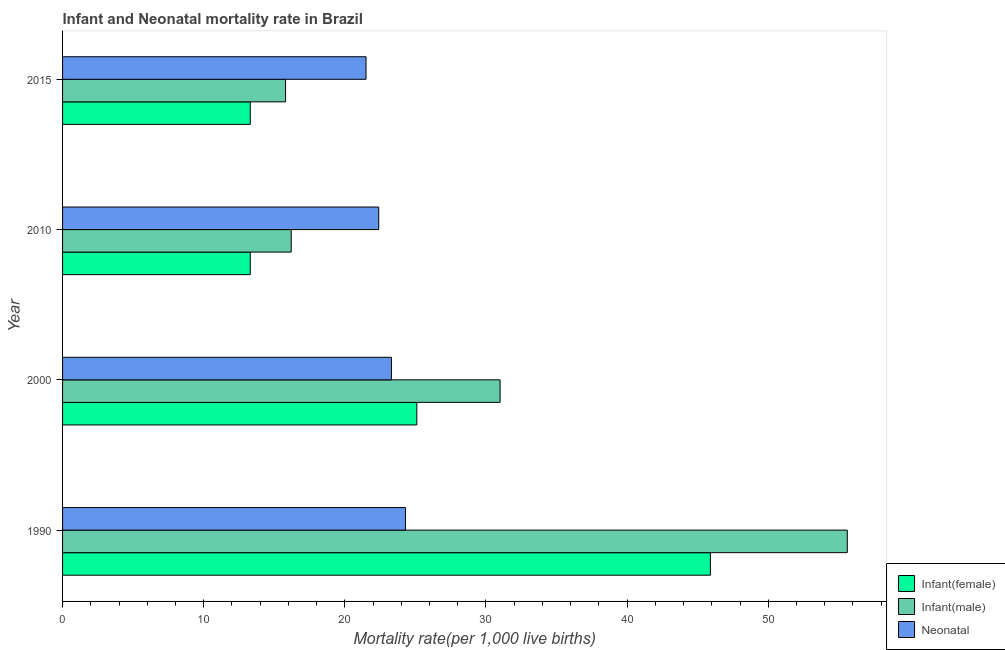How many different coloured bars are there?
Provide a succinct answer. 3. Are the number of bars on each tick of the Y-axis equal?
Give a very brief answer. Yes. How many bars are there on the 2nd tick from the top?
Provide a succinct answer. 3. In how many cases, is the number of bars for a given year not equal to the number of legend labels?
Give a very brief answer. 0. What is the neonatal mortality rate in 2015?
Offer a very short reply. 21.5. Across all years, what is the maximum neonatal mortality rate?
Make the answer very short. 24.3. Across all years, what is the minimum neonatal mortality rate?
Your answer should be compact. 21.5. In which year was the neonatal mortality rate minimum?
Keep it short and to the point. 2015. What is the total neonatal mortality rate in the graph?
Ensure brevity in your answer.  91.5. What is the difference between the infant mortality rate(female) in 2000 and the infant mortality rate(male) in 2010?
Your answer should be very brief. 8.9. What is the average infant mortality rate(female) per year?
Offer a terse response. 24.4. In the year 1990, what is the difference between the infant mortality rate(male) and infant mortality rate(female)?
Keep it short and to the point. 9.7. In how many years, is the infant mortality rate(male) greater than 40 ?
Your answer should be very brief. 1. What is the ratio of the infant mortality rate(female) in 1990 to that in 2000?
Ensure brevity in your answer.  1.83. What is the difference between the highest and the second highest infant mortality rate(male)?
Make the answer very short. 24.6. What is the difference between the highest and the lowest infant mortality rate(male)?
Your response must be concise. 39.8. What does the 3rd bar from the top in 2000 represents?
Your answer should be very brief. Infant(female). What does the 3rd bar from the bottom in 2010 represents?
Keep it short and to the point. Neonatal . How many bars are there?
Keep it short and to the point. 12. How many years are there in the graph?
Keep it short and to the point. 4. What is the difference between two consecutive major ticks on the X-axis?
Your response must be concise. 10. Are the values on the major ticks of X-axis written in scientific E-notation?
Offer a terse response. No. Does the graph contain grids?
Ensure brevity in your answer.  No. What is the title of the graph?
Your response must be concise. Infant and Neonatal mortality rate in Brazil. Does "Ages 15-20" appear as one of the legend labels in the graph?
Your response must be concise. No. What is the label or title of the X-axis?
Your answer should be compact. Mortality rate(per 1,0 live births). What is the label or title of the Y-axis?
Provide a short and direct response. Year. What is the Mortality rate(per 1,000 live births) in Infant(female) in 1990?
Offer a terse response. 45.9. What is the Mortality rate(per 1,000 live births) in Infant(male) in 1990?
Give a very brief answer. 55.6. What is the Mortality rate(per 1,000 live births) in Neonatal  in 1990?
Keep it short and to the point. 24.3. What is the Mortality rate(per 1,000 live births) in Infant(female) in 2000?
Offer a terse response. 25.1. What is the Mortality rate(per 1,000 live births) in Neonatal  in 2000?
Keep it short and to the point. 23.3. What is the Mortality rate(per 1,000 live births) in Neonatal  in 2010?
Keep it short and to the point. 22.4. Across all years, what is the maximum Mortality rate(per 1,000 live births) of Infant(female)?
Your response must be concise. 45.9. Across all years, what is the maximum Mortality rate(per 1,000 live births) of Infant(male)?
Your response must be concise. 55.6. Across all years, what is the maximum Mortality rate(per 1,000 live births) of Neonatal ?
Keep it short and to the point. 24.3. Across all years, what is the minimum Mortality rate(per 1,000 live births) of Infant(female)?
Your response must be concise. 13.3. What is the total Mortality rate(per 1,000 live births) of Infant(female) in the graph?
Your response must be concise. 97.6. What is the total Mortality rate(per 1,000 live births) of Infant(male) in the graph?
Your answer should be compact. 118.6. What is the total Mortality rate(per 1,000 live births) in Neonatal  in the graph?
Ensure brevity in your answer.  91.5. What is the difference between the Mortality rate(per 1,000 live births) in Infant(female) in 1990 and that in 2000?
Your answer should be compact. 20.8. What is the difference between the Mortality rate(per 1,000 live births) in Infant(male) in 1990 and that in 2000?
Make the answer very short. 24.6. What is the difference between the Mortality rate(per 1,000 live births) in Infant(female) in 1990 and that in 2010?
Give a very brief answer. 32.6. What is the difference between the Mortality rate(per 1,000 live births) in Infant(male) in 1990 and that in 2010?
Give a very brief answer. 39.4. What is the difference between the Mortality rate(per 1,000 live births) in Infant(female) in 1990 and that in 2015?
Provide a succinct answer. 32.6. What is the difference between the Mortality rate(per 1,000 live births) in Infant(male) in 1990 and that in 2015?
Give a very brief answer. 39.8. What is the difference between the Mortality rate(per 1,000 live births) in Neonatal  in 1990 and that in 2015?
Your answer should be compact. 2.8. What is the difference between the Mortality rate(per 1,000 live births) in Infant(female) in 2000 and that in 2010?
Offer a very short reply. 11.8. What is the difference between the Mortality rate(per 1,000 live births) in Infant(female) in 2000 and that in 2015?
Ensure brevity in your answer.  11.8. What is the difference between the Mortality rate(per 1,000 live births) in Infant(male) in 2010 and that in 2015?
Your answer should be very brief. 0.4. What is the difference between the Mortality rate(per 1,000 live births) in Infant(female) in 1990 and the Mortality rate(per 1,000 live births) in Neonatal  in 2000?
Your answer should be compact. 22.6. What is the difference between the Mortality rate(per 1,000 live births) in Infant(male) in 1990 and the Mortality rate(per 1,000 live births) in Neonatal  in 2000?
Offer a very short reply. 32.3. What is the difference between the Mortality rate(per 1,000 live births) of Infant(female) in 1990 and the Mortality rate(per 1,000 live births) of Infant(male) in 2010?
Offer a terse response. 29.7. What is the difference between the Mortality rate(per 1,000 live births) in Infant(female) in 1990 and the Mortality rate(per 1,000 live births) in Neonatal  in 2010?
Your answer should be very brief. 23.5. What is the difference between the Mortality rate(per 1,000 live births) of Infant(male) in 1990 and the Mortality rate(per 1,000 live births) of Neonatal  in 2010?
Your response must be concise. 33.2. What is the difference between the Mortality rate(per 1,000 live births) of Infant(female) in 1990 and the Mortality rate(per 1,000 live births) of Infant(male) in 2015?
Your answer should be very brief. 30.1. What is the difference between the Mortality rate(per 1,000 live births) in Infant(female) in 1990 and the Mortality rate(per 1,000 live births) in Neonatal  in 2015?
Provide a succinct answer. 24.4. What is the difference between the Mortality rate(per 1,000 live births) in Infant(male) in 1990 and the Mortality rate(per 1,000 live births) in Neonatal  in 2015?
Provide a succinct answer. 34.1. What is the difference between the Mortality rate(per 1,000 live births) of Infant(female) in 2000 and the Mortality rate(per 1,000 live births) of Neonatal  in 2010?
Make the answer very short. 2.7. What is the difference between the Mortality rate(per 1,000 live births) in Infant(female) in 2000 and the Mortality rate(per 1,000 live births) in Infant(male) in 2015?
Your response must be concise. 9.3. What is the difference between the Mortality rate(per 1,000 live births) of Infant(male) in 2000 and the Mortality rate(per 1,000 live births) of Neonatal  in 2015?
Provide a short and direct response. 9.5. What is the difference between the Mortality rate(per 1,000 live births) in Infant(male) in 2010 and the Mortality rate(per 1,000 live births) in Neonatal  in 2015?
Your answer should be very brief. -5.3. What is the average Mortality rate(per 1,000 live births) in Infant(female) per year?
Ensure brevity in your answer.  24.4. What is the average Mortality rate(per 1,000 live births) of Infant(male) per year?
Your response must be concise. 29.65. What is the average Mortality rate(per 1,000 live births) in Neonatal  per year?
Your answer should be very brief. 22.88. In the year 1990, what is the difference between the Mortality rate(per 1,000 live births) of Infant(female) and Mortality rate(per 1,000 live births) of Infant(male)?
Make the answer very short. -9.7. In the year 1990, what is the difference between the Mortality rate(per 1,000 live births) in Infant(female) and Mortality rate(per 1,000 live births) in Neonatal ?
Make the answer very short. 21.6. In the year 1990, what is the difference between the Mortality rate(per 1,000 live births) in Infant(male) and Mortality rate(per 1,000 live births) in Neonatal ?
Provide a short and direct response. 31.3. In the year 2000, what is the difference between the Mortality rate(per 1,000 live births) of Infant(female) and Mortality rate(per 1,000 live births) of Neonatal ?
Your answer should be compact. 1.8. In the year 2010, what is the difference between the Mortality rate(per 1,000 live births) of Infant(male) and Mortality rate(per 1,000 live births) of Neonatal ?
Your answer should be compact. -6.2. In the year 2015, what is the difference between the Mortality rate(per 1,000 live births) in Infant(female) and Mortality rate(per 1,000 live births) in Neonatal ?
Your response must be concise. -8.2. What is the ratio of the Mortality rate(per 1,000 live births) of Infant(female) in 1990 to that in 2000?
Ensure brevity in your answer.  1.83. What is the ratio of the Mortality rate(per 1,000 live births) of Infant(male) in 1990 to that in 2000?
Your response must be concise. 1.79. What is the ratio of the Mortality rate(per 1,000 live births) in Neonatal  in 1990 to that in 2000?
Make the answer very short. 1.04. What is the ratio of the Mortality rate(per 1,000 live births) of Infant(female) in 1990 to that in 2010?
Your answer should be very brief. 3.45. What is the ratio of the Mortality rate(per 1,000 live births) in Infant(male) in 1990 to that in 2010?
Keep it short and to the point. 3.43. What is the ratio of the Mortality rate(per 1,000 live births) in Neonatal  in 1990 to that in 2010?
Give a very brief answer. 1.08. What is the ratio of the Mortality rate(per 1,000 live births) in Infant(female) in 1990 to that in 2015?
Provide a short and direct response. 3.45. What is the ratio of the Mortality rate(per 1,000 live births) of Infant(male) in 1990 to that in 2015?
Your answer should be very brief. 3.52. What is the ratio of the Mortality rate(per 1,000 live births) of Neonatal  in 1990 to that in 2015?
Ensure brevity in your answer.  1.13. What is the ratio of the Mortality rate(per 1,000 live births) of Infant(female) in 2000 to that in 2010?
Ensure brevity in your answer.  1.89. What is the ratio of the Mortality rate(per 1,000 live births) of Infant(male) in 2000 to that in 2010?
Make the answer very short. 1.91. What is the ratio of the Mortality rate(per 1,000 live births) in Neonatal  in 2000 to that in 2010?
Give a very brief answer. 1.04. What is the ratio of the Mortality rate(per 1,000 live births) of Infant(female) in 2000 to that in 2015?
Offer a terse response. 1.89. What is the ratio of the Mortality rate(per 1,000 live births) in Infant(male) in 2000 to that in 2015?
Offer a very short reply. 1.96. What is the ratio of the Mortality rate(per 1,000 live births) in Neonatal  in 2000 to that in 2015?
Your answer should be compact. 1.08. What is the ratio of the Mortality rate(per 1,000 live births) of Infant(male) in 2010 to that in 2015?
Ensure brevity in your answer.  1.03. What is the ratio of the Mortality rate(per 1,000 live births) of Neonatal  in 2010 to that in 2015?
Offer a terse response. 1.04. What is the difference between the highest and the second highest Mortality rate(per 1,000 live births) of Infant(female)?
Your response must be concise. 20.8. What is the difference between the highest and the second highest Mortality rate(per 1,000 live births) in Infant(male)?
Keep it short and to the point. 24.6. What is the difference between the highest and the lowest Mortality rate(per 1,000 live births) of Infant(female)?
Keep it short and to the point. 32.6. What is the difference between the highest and the lowest Mortality rate(per 1,000 live births) of Infant(male)?
Offer a terse response. 39.8. 